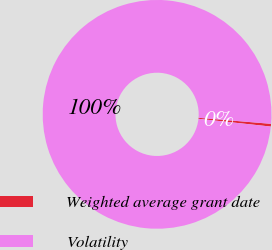Convert chart to OTSL. <chart><loc_0><loc_0><loc_500><loc_500><pie_chart><fcel>Weighted average grant date<fcel>Volatility<nl><fcel>0.38%<fcel>99.62%<nl></chart> 